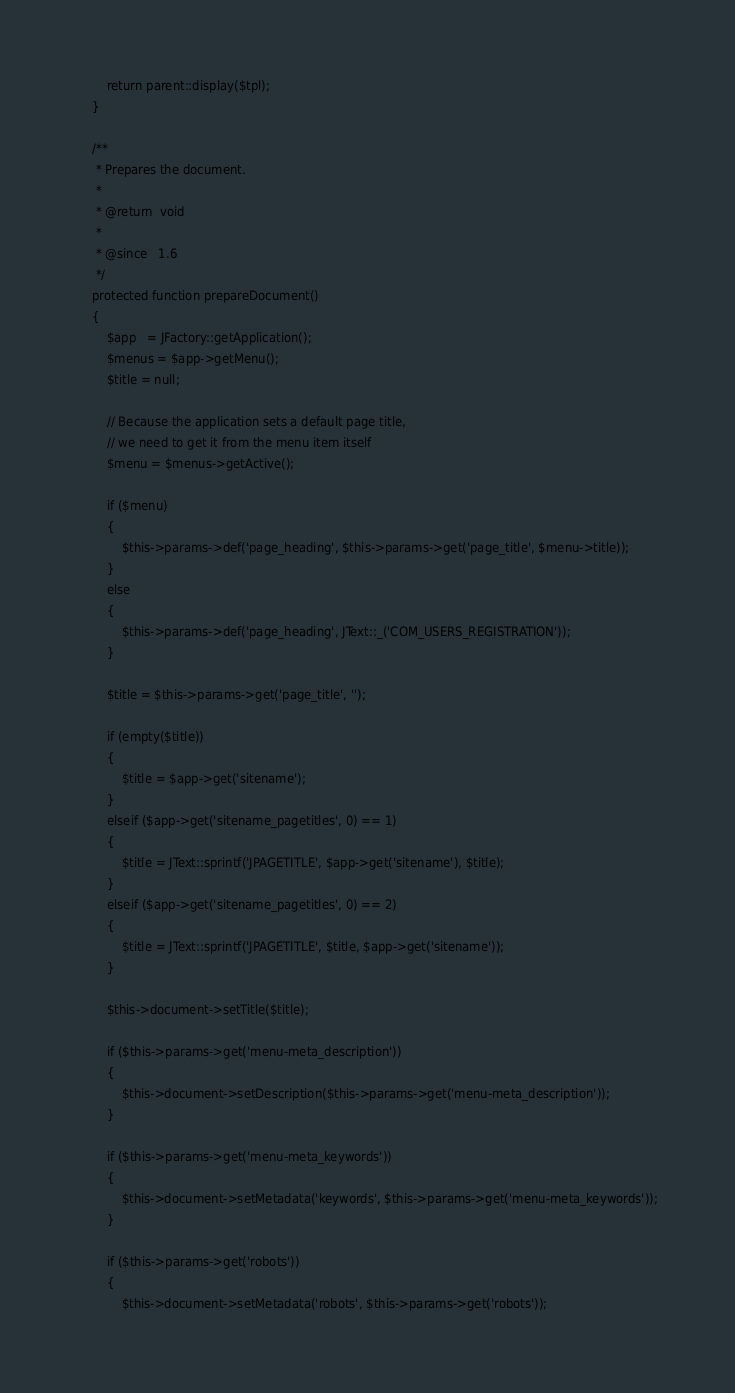Convert code to text. <code><loc_0><loc_0><loc_500><loc_500><_PHP_>
		return parent::display($tpl);
	}

	/**
	 * Prepares the document.
	 *
	 * @return  void
	 *
	 * @since   1.6
	 */
	protected function prepareDocument()
	{
		$app   = JFactory::getApplication();
		$menus = $app->getMenu();
		$title = null;

		// Because the application sets a default page title,
		// we need to get it from the menu item itself
		$menu = $menus->getActive();

		if ($menu)
		{
			$this->params->def('page_heading', $this->params->get('page_title', $menu->title));
		}
		else
		{
			$this->params->def('page_heading', JText::_('COM_USERS_REGISTRATION'));
		}

		$title = $this->params->get('page_title', '');

		if (empty($title))
		{
			$title = $app->get('sitename');
		}
		elseif ($app->get('sitename_pagetitles', 0) == 1)
		{
			$title = JText::sprintf('JPAGETITLE', $app->get('sitename'), $title);
		}
		elseif ($app->get('sitename_pagetitles', 0) == 2)
		{
			$title = JText::sprintf('JPAGETITLE', $title, $app->get('sitename'));
		}

		$this->document->setTitle($title);

		if ($this->params->get('menu-meta_description'))
		{
			$this->document->setDescription($this->params->get('menu-meta_description'));
		}

		if ($this->params->get('menu-meta_keywords'))
		{
			$this->document->setMetadata('keywords', $this->params->get('menu-meta_keywords'));
		}

		if ($this->params->get('robots'))
		{
			$this->document->setMetadata('robots', $this->params->get('robots'));</code> 